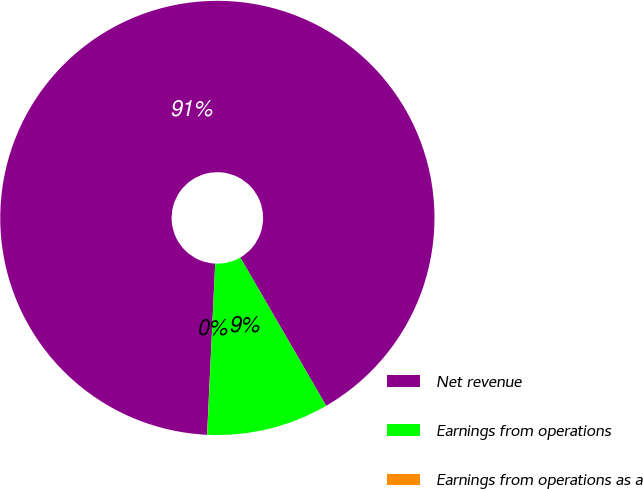Convert chart to OTSL. <chart><loc_0><loc_0><loc_500><loc_500><pie_chart><fcel>Net revenue<fcel>Earnings from operations<fcel>Earnings from operations as a<nl><fcel>90.89%<fcel>9.1%<fcel>0.01%<nl></chart> 